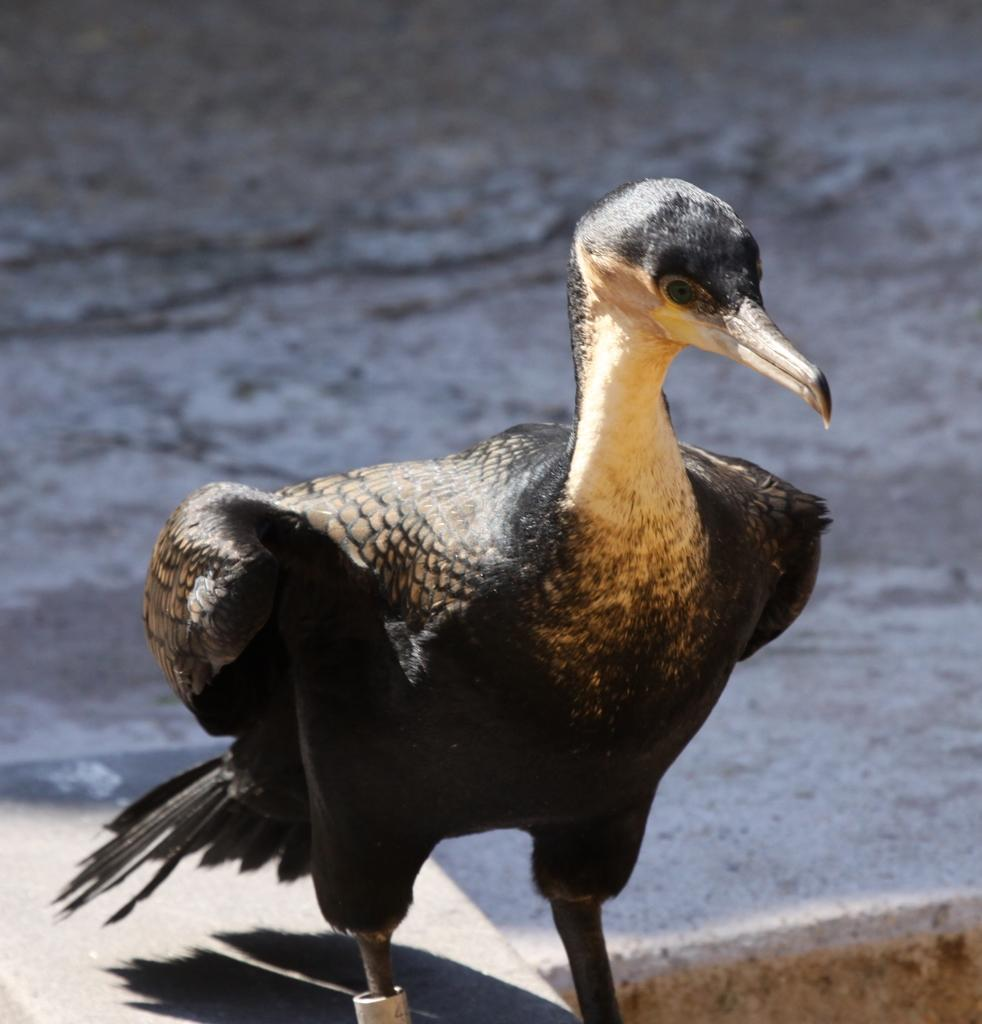What is located in the center of the image? There is a bird in the center of the image. What can be seen in the background of the image? There is water visible in the background of the image. What color is the bird's mind in the image? The bird does not have a mind with a color in the image, as a bird's mind is not visible. What type of orange fruit can be seen in the image? There is no orange fruit present in the image. 